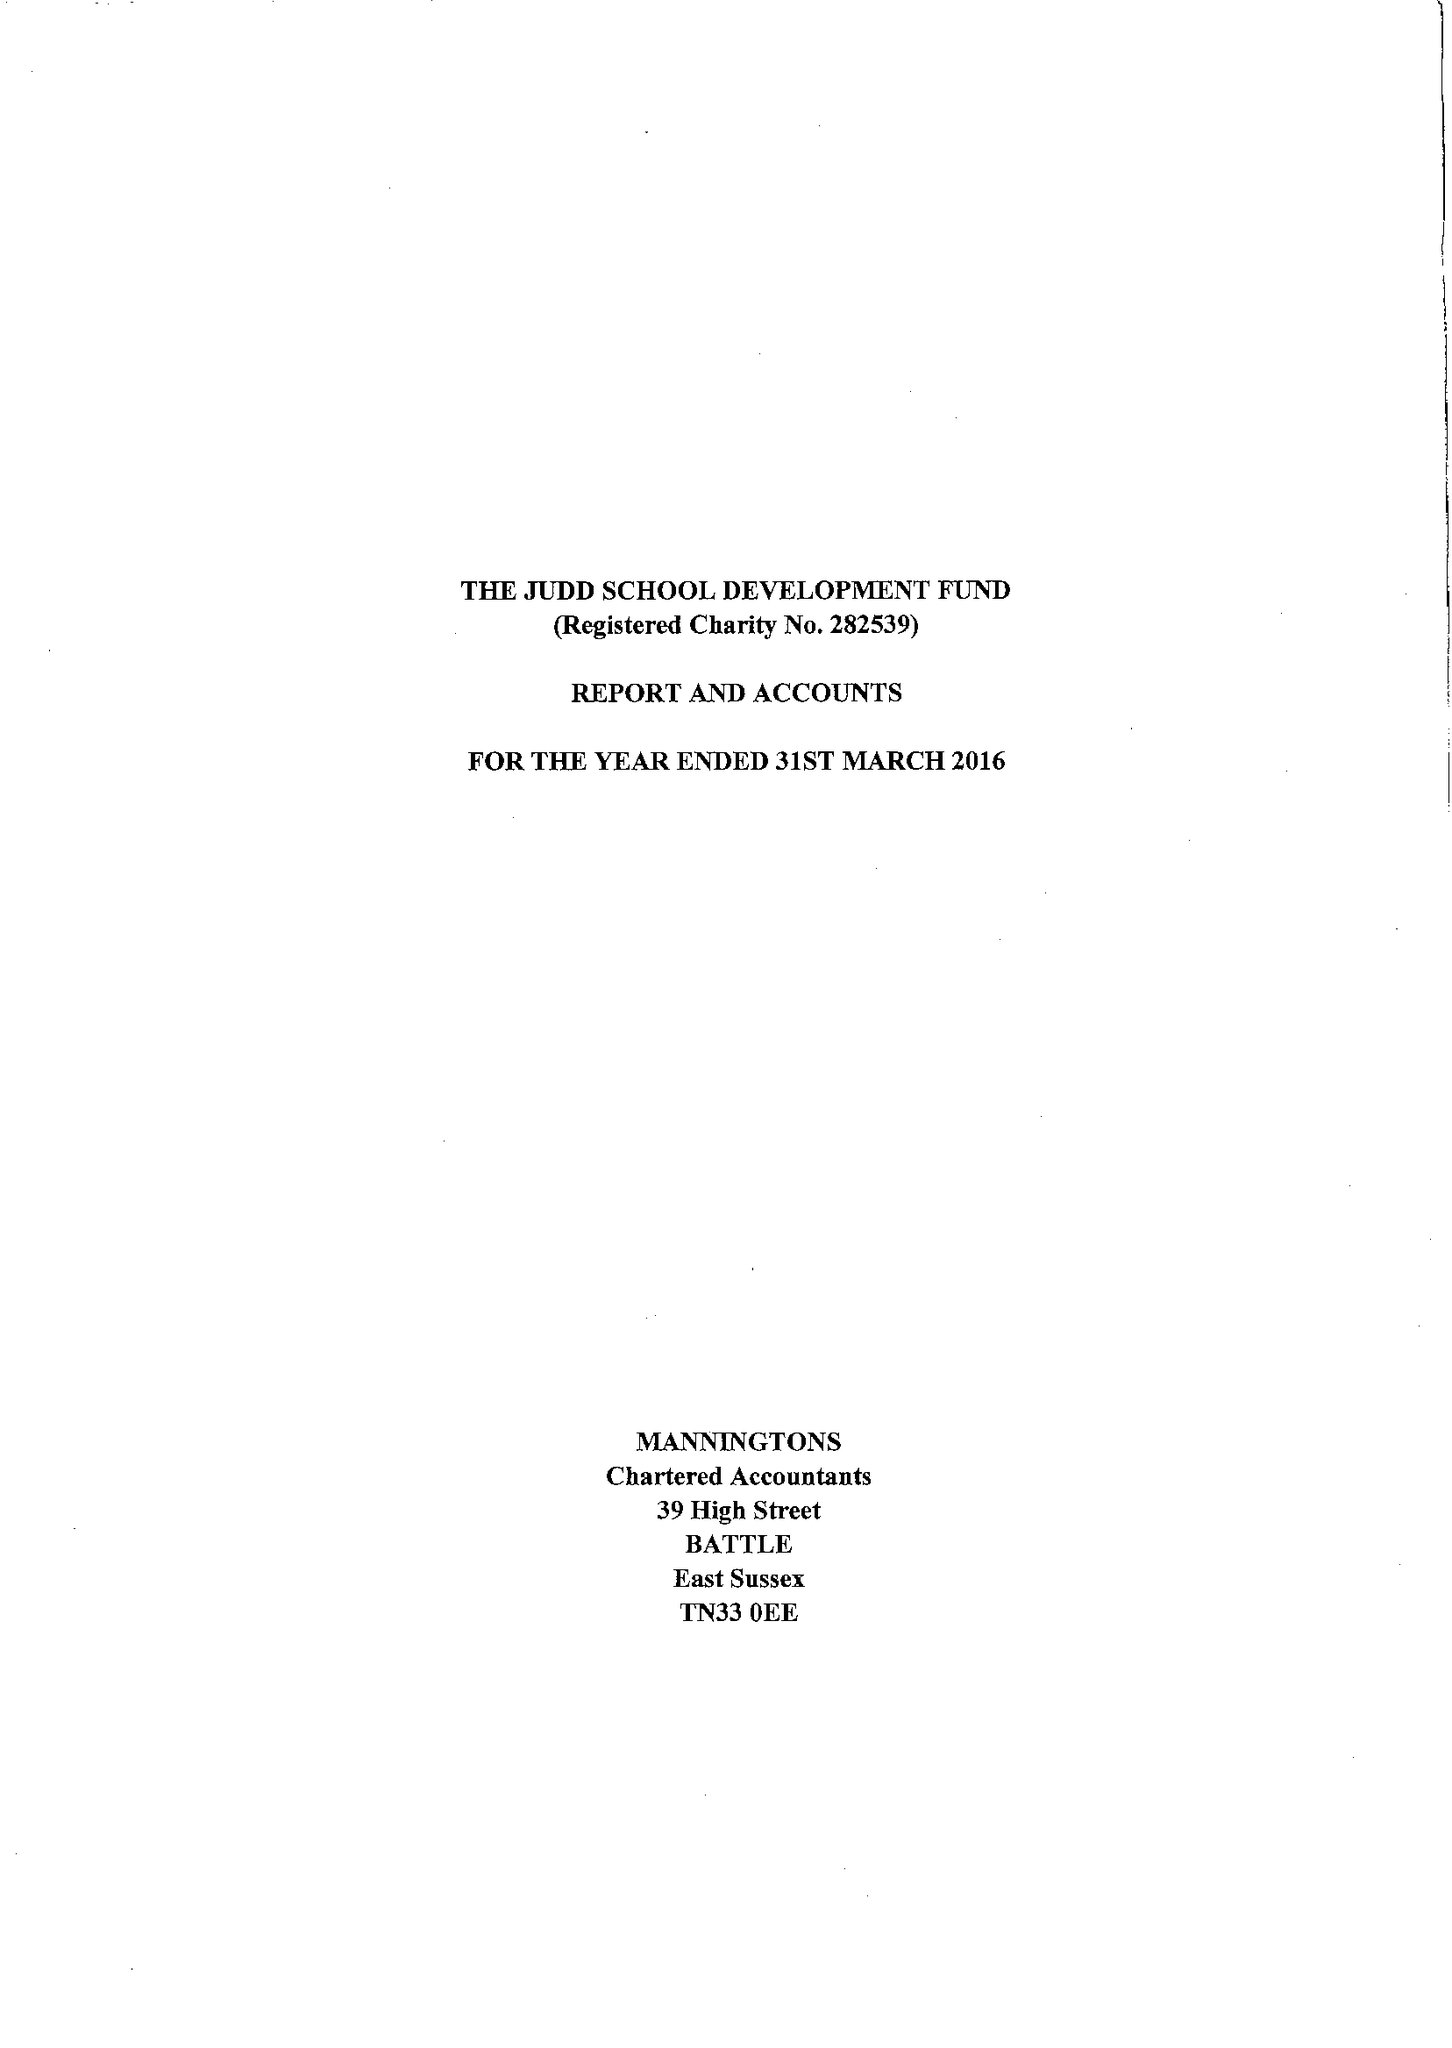What is the value for the address__post_town?
Answer the question using a single word or phrase. LONDON 